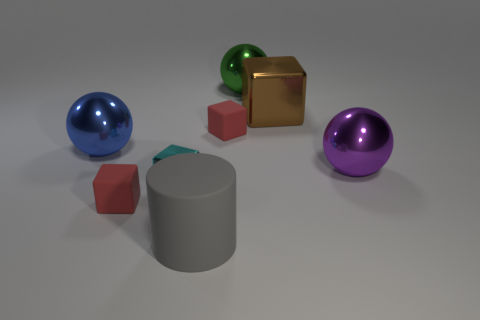Subtract 1 blocks. How many blocks are left? 3 Subtract all gray blocks. Subtract all cyan cylinders. How many blocks are left? 4 Add 1 green matte objects. How many objects exist? 9 Subtract all balls. How many objects are left? 5 Subtract 0 gray balls. How many objects are left? 8 Subtract all green balls. Subtract all big things. How many objects are left? 2 Add 2 small red matte things. How many small red matte things are left? 4 Add 5 matte things. How many matte things exist? 8 